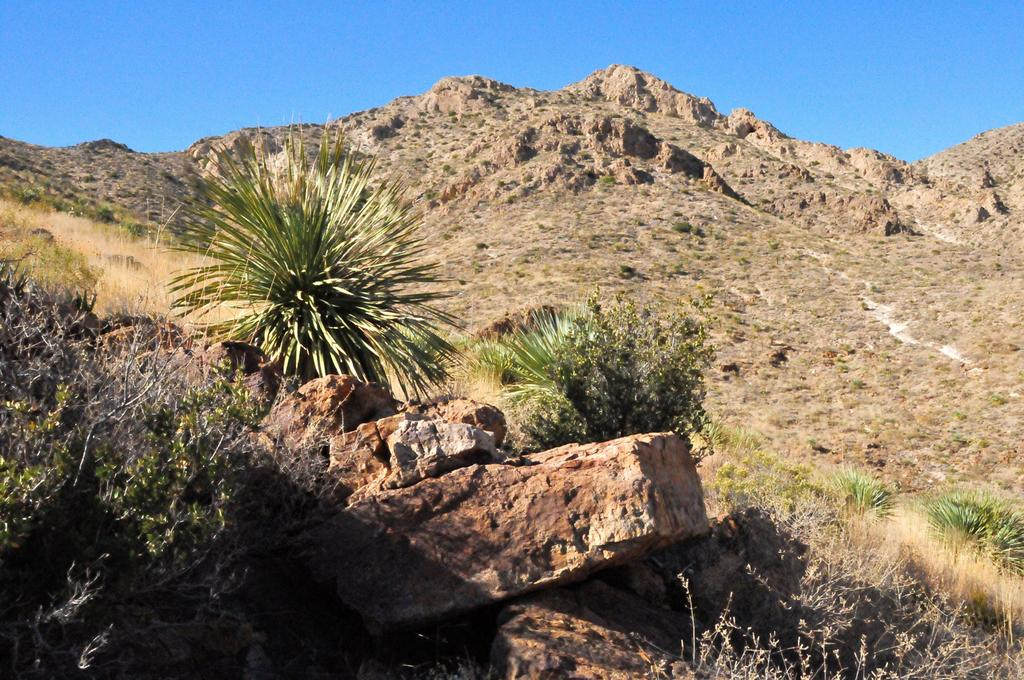What type of natural elements can be seen in the image? There are rocks in the image. What else is present alongside the rocks? There are plants on either side of the rocks. What can be seen in the distance in the image? There are mountains in the background of the image. What type of milk does the mother use to act in the image? There is no mother, milk, or act present in the image; it features rocks, plants, and mountains. 